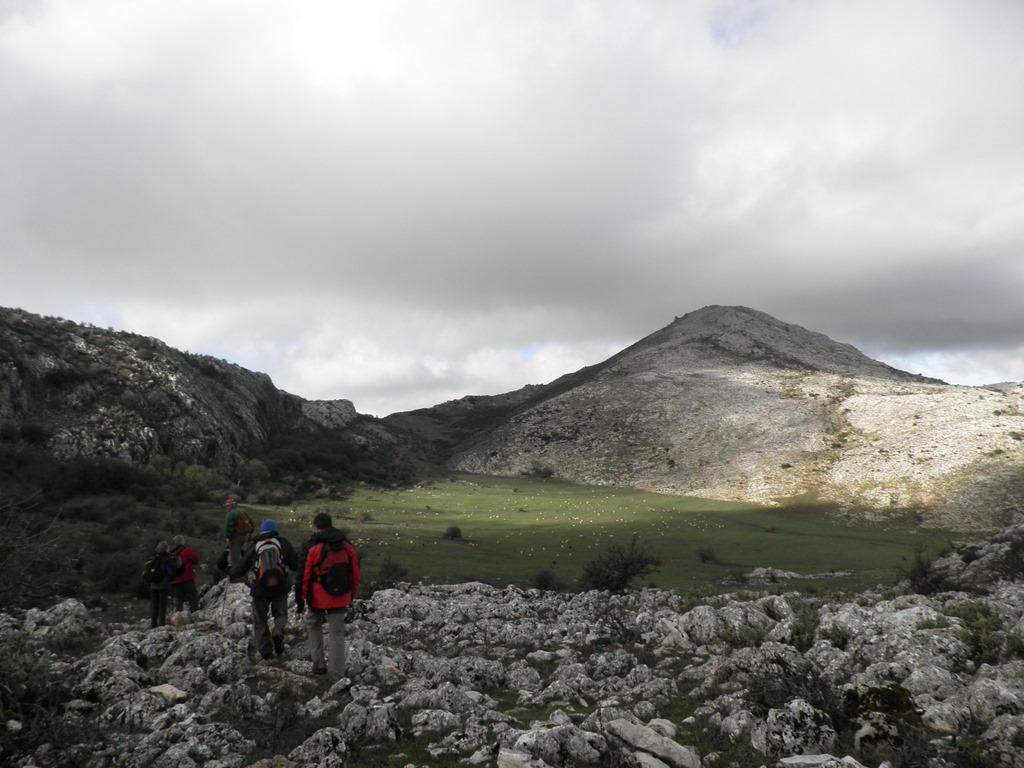How many people are in the image? There are people in the image, but the exact number is not specified. What are the people carrying on their backs? The people are wearing backpacks. What type of terrain are the people walking on? The people are walking on rocks. What type of vegetation is visible in the image? There is grass visible in the image. What can be seen in the distance in the image? There are hills in the background of the image. What is the weather like in the image? The sky is cloudy in the background of the image. Can you tell me how many goldfish are swimming in the image? There are no goldfish present in the image. What type of fruit is the person holding in the image? There is no fruit or person holding anything visible in the image. 